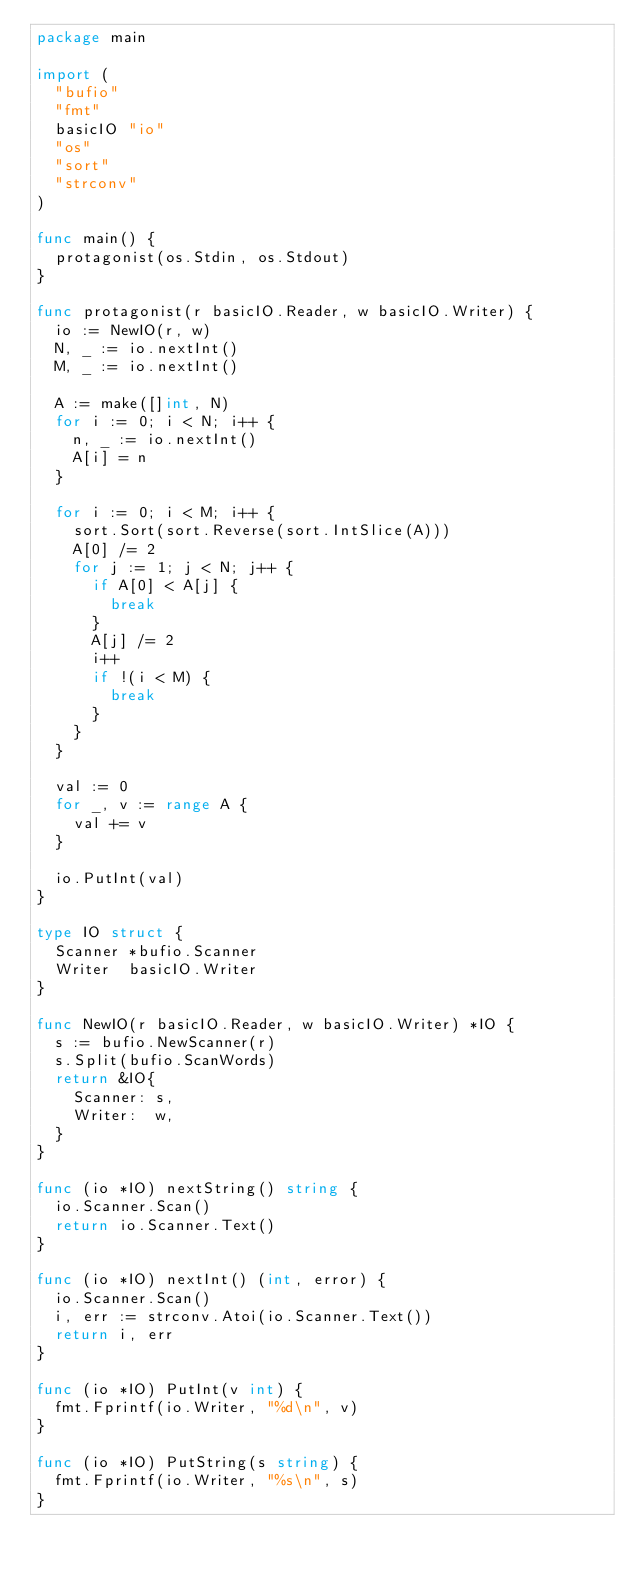<code> <loc_0><loc_0><loc_500><loc_500><_Go_>package main

import (
	"bufio"
	"fmt"
	basicIO "io"
	"os"
	"sort"
	"strconv"
)

func main() {
	protagonist(os.Stdin, os.Stdout)
}

func protagonist(r basicIO.Reader, w basicIO.Writer) {
	io := NewIO(r, w)
	N, _ := io.nextInt()
	M, _ := io.nextInt()

	A := make([]int, N)
	for i := 0; i < N; i++ {
		n, _ := io.nextInt()
		A[i] = n
	}

	for i := 0; i < M; i++ {
		sort.Sort(sort.Reverse(sort.IntSlice(A)))
		A[0] /= 2
		for j := 1; j < N; j++ {
			if A[0] < A[j] {
				break
			}
			A[j] /= 2
			i++
			if !(i < M) {
				break
			}
		}
	}

	val := 0
	for _, v := range A {
		val += v
	}

	io.PutInt(val)
}

type IO struct {
	Scanner *bufio.Scanner
	Writer  basicIO.Writer
}

func NewIO(r basicIO.Reader, w basicIO.Writer) *IO {
	s := bufio.NewScanner(r)
	s.Split(bufio.ScanWords)
	return &IO{
		Scanner: s,
		Writer:  w,
	}
}

func (io *IO) nextString() string {
	io.Scanner.Scan()
	return io.Scanner.Text()
}

func (io *IO) nextInt() (int, error) {
	io.Scanner.Scan()
	i, err := strconv.Atoi(io.Scanner.Text())
	return i, err
}

func (io *IO) PutInt(v int) {
	fmt.Fprintf(io.Writer, "%d\n", v)
}

func (io *IO) PutString(s string) {
	fmt.Fprintf(io.Writer, "%s\n", s)
}
</code> 